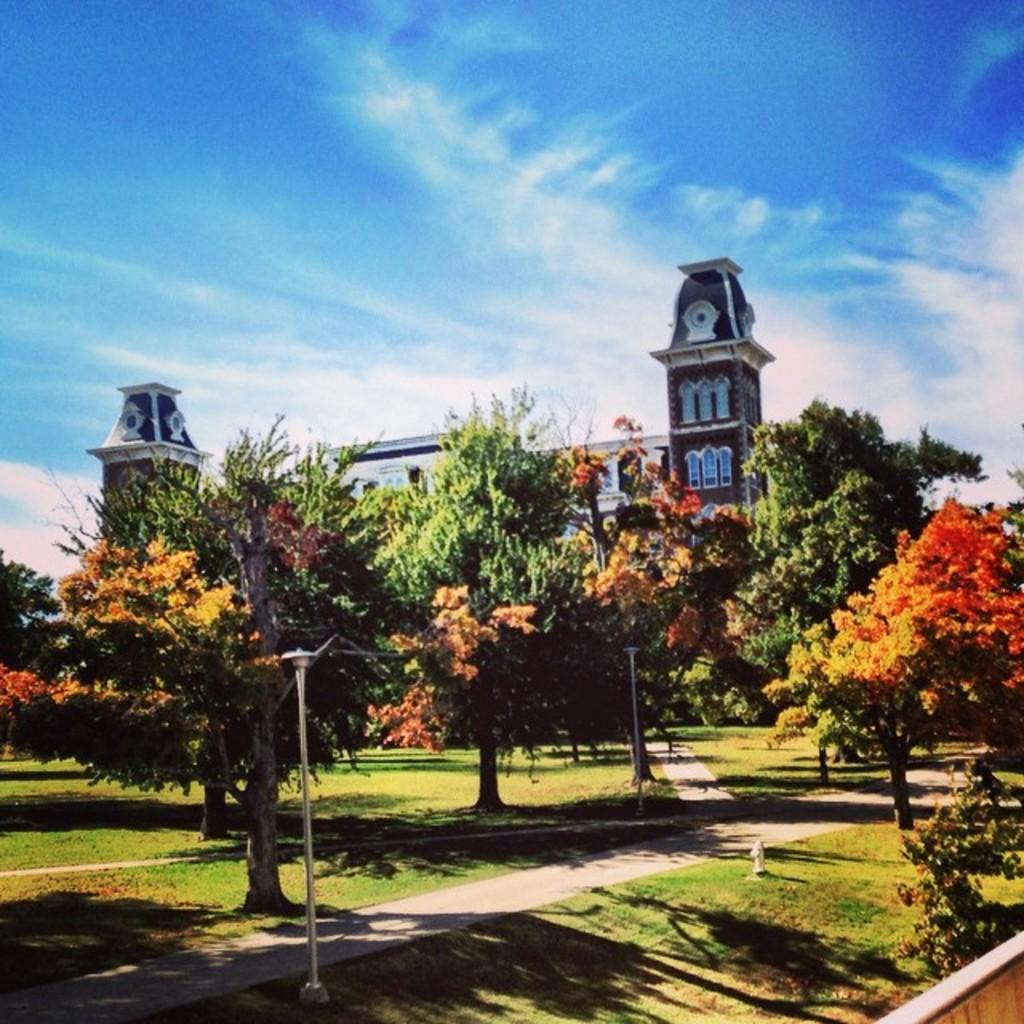Can you describe this image briefly? In this image there are trees, building, plants, and at the bottom there is a walkway and grass and objects. And at the top of the image there is sky. 